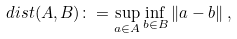Convert formula to latex. <formula><loc_0><loc_0><loc_500><loc_500>d i s t ( A , B ) \colon = \sup _ { a \in A } \inf _ { b \in B } \| a - b \| \, ,</formula> 